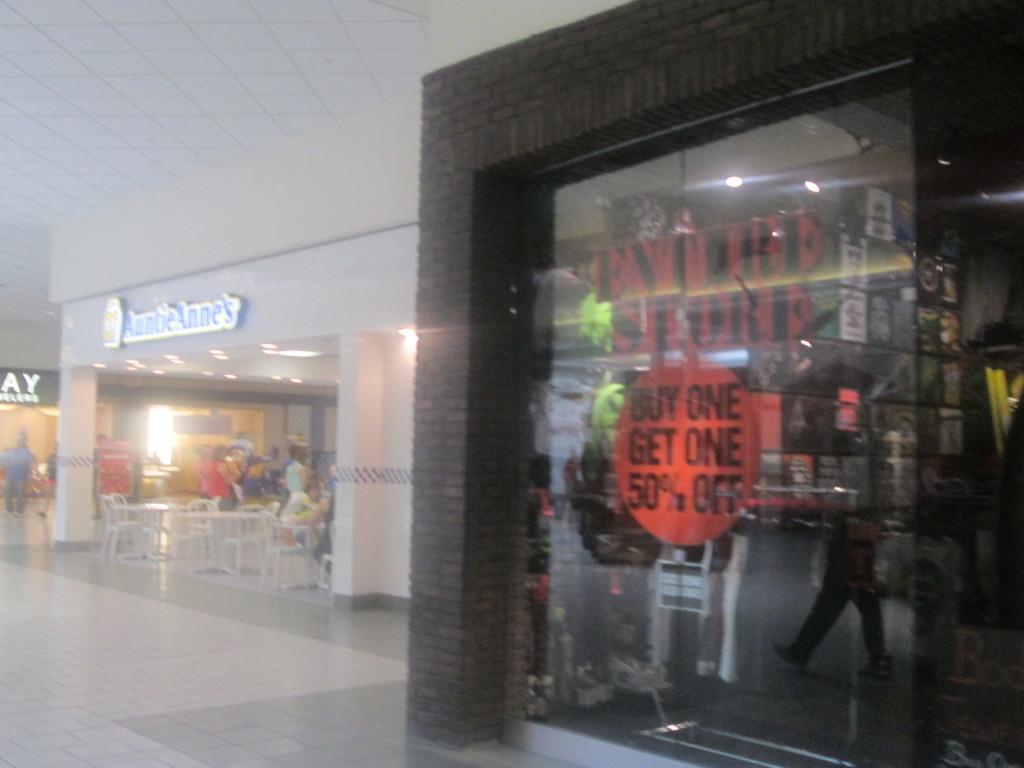In one or two sentences, can you explain what this image depicts? In the picture we can see inside view of the mall with a shop which is brown in color with glasses and beside it, we can see another shop with table and chairs and beside it also we can see another shop with a light and a man standing near it. 